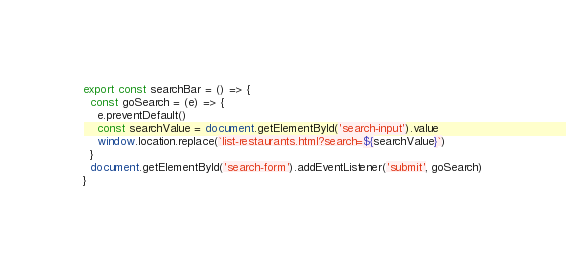<code> <loc_0><loc_0><loc_500><loc_500><_JavaScript_>export const searchBar = () => {
  const goSearch = (e) => {
    e.preventDefault()
    const searchValue = document.getElementById('search-input').value
    window.location.replace(`list-restaurants.html?search=${searchValue}`)
  }
  document.getElementById('search-form').addEventListener('submit', goSearch)
}
</code> 